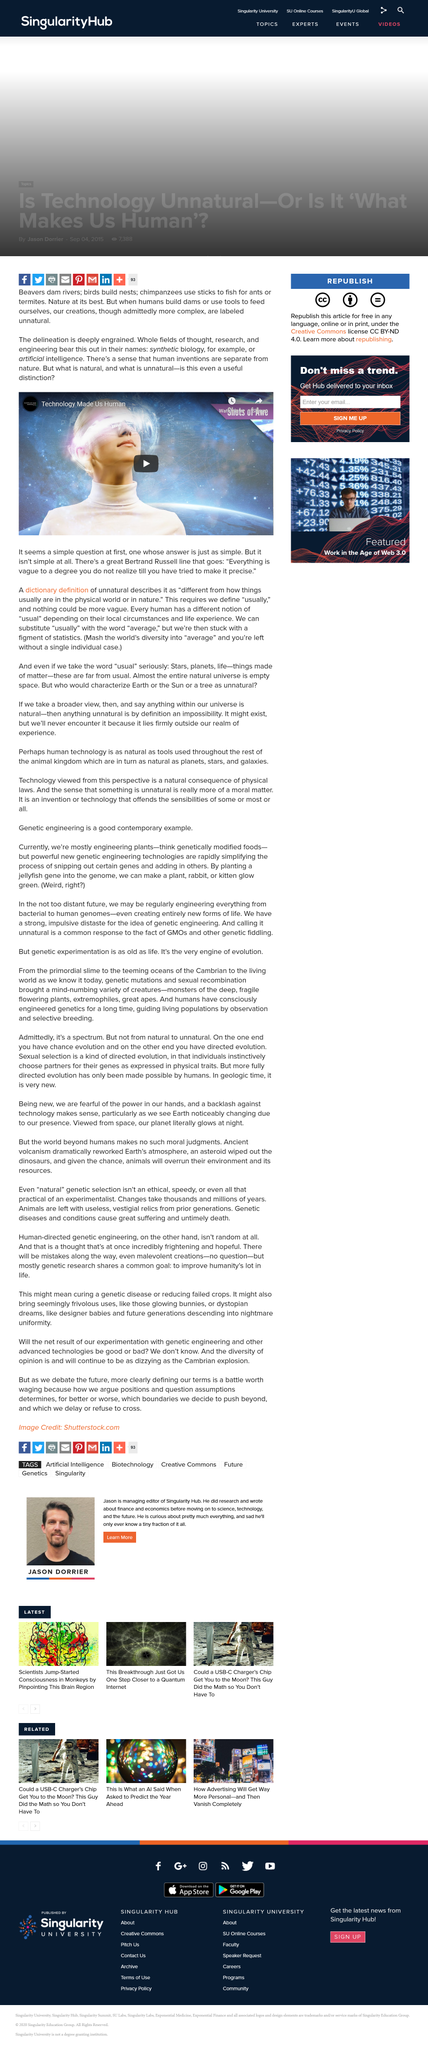Point out several critical features in this image. There is a perception that human inventions are distinct from nature. The question of whether the distinction between what is natural and what is unnatural is a useful distinction seems simple at first, but it is actually quite complex. Bertrand Russell stated that "everything is vague to a degree that one does not realize its vagueness until attempting to make it precise. 